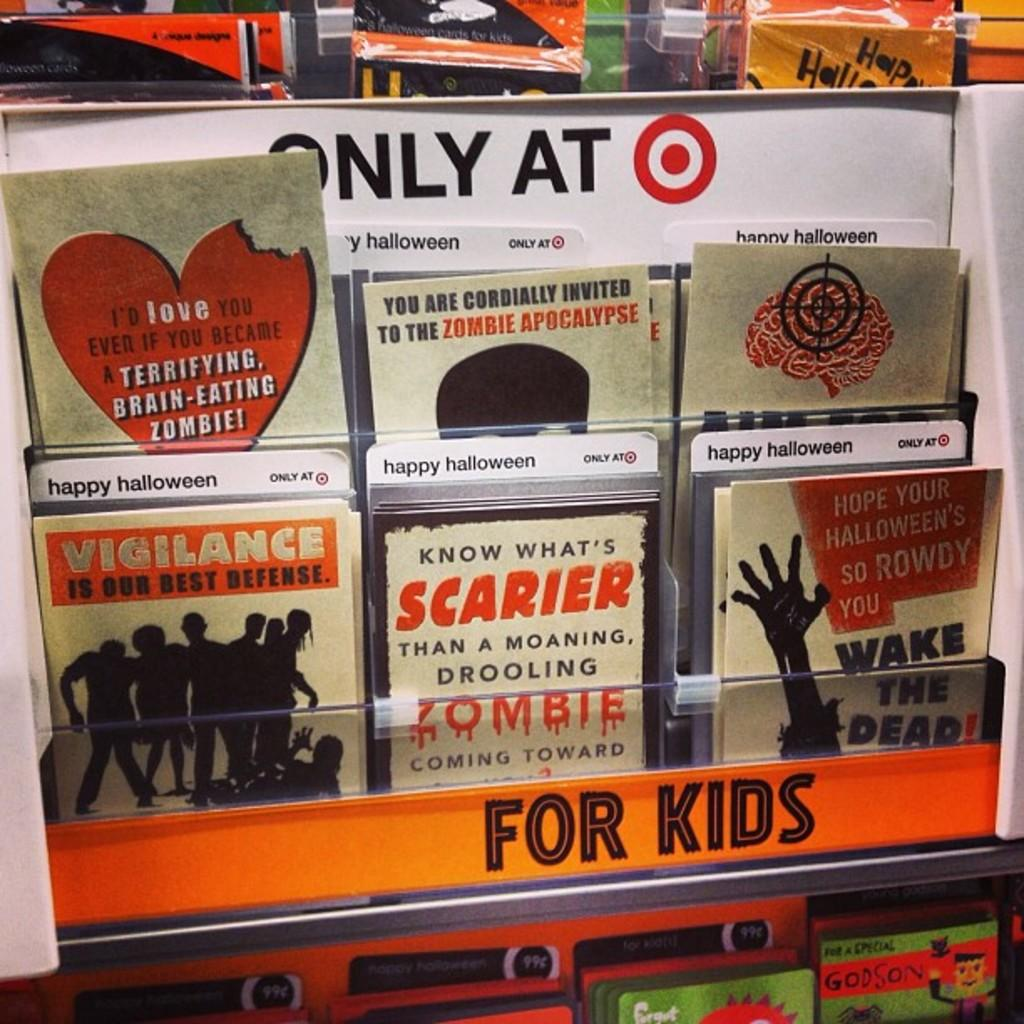<image>
Present a compact description of the photo's key features. Halloween cards for sale only at Target, one says Vigilance is our best defense. 